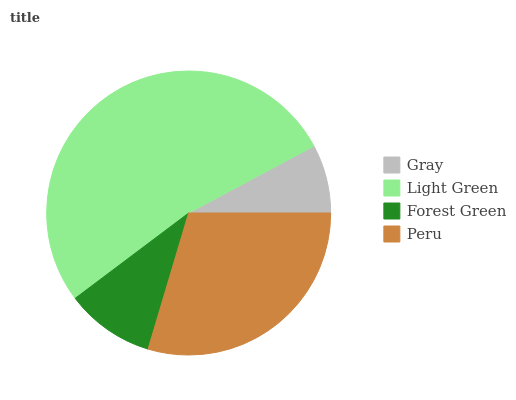Is Gray the minimum?
Answer yes or no. Yes. Is Light Green the maximum?
Answer yes or no. Yes. Is Forest Green the minimum?
Answer yes or no. No. Is Forest Green the maximum?
Answer yes or no. No. Is Light Green greater than Forest Green?
Answer yes or no. Yes. Is Forest Green less than Light Green?
Answer yes or no. Yes. Is Forest Green greater than Light Green?
Answer yes or no. No. Is Light Green less than Forest Green?
Answer yes or no. No. Is Peru the high median?
Answer yes or no. Yes. Is Forest Green the low median?
Answer yes or no. Yes. Is Light Green the high median?
Answer yes or no. No. Is Gray the low median?
Answer yes or no. No. 